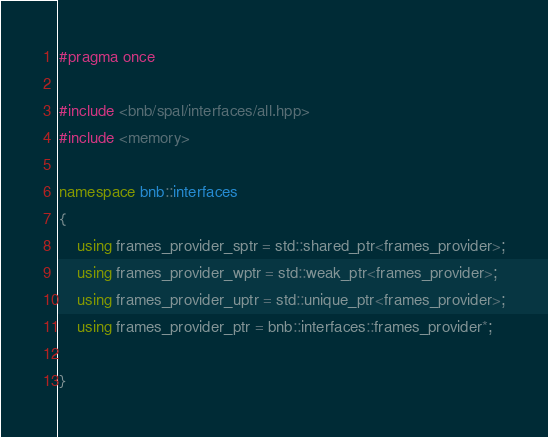<code> <loc_0><loc_0><loc_500><loc_500><_C++_>#pragma once

#include <bnb/spal/interfaces/all.hpp>
#include <memory>

namespace bnb::interfaces
{
    using frames_provider_sptr = std::shared_ptr<frames_provider>;
    using frames_provider_wptr = std::weak_ptr<frames_provider>;
    using frames_provider_uptr = std::unique_ptr<frames_provider>;
    using frames_provider_ptr = bnb::interfaces::frames_provider*;

}
</code> 